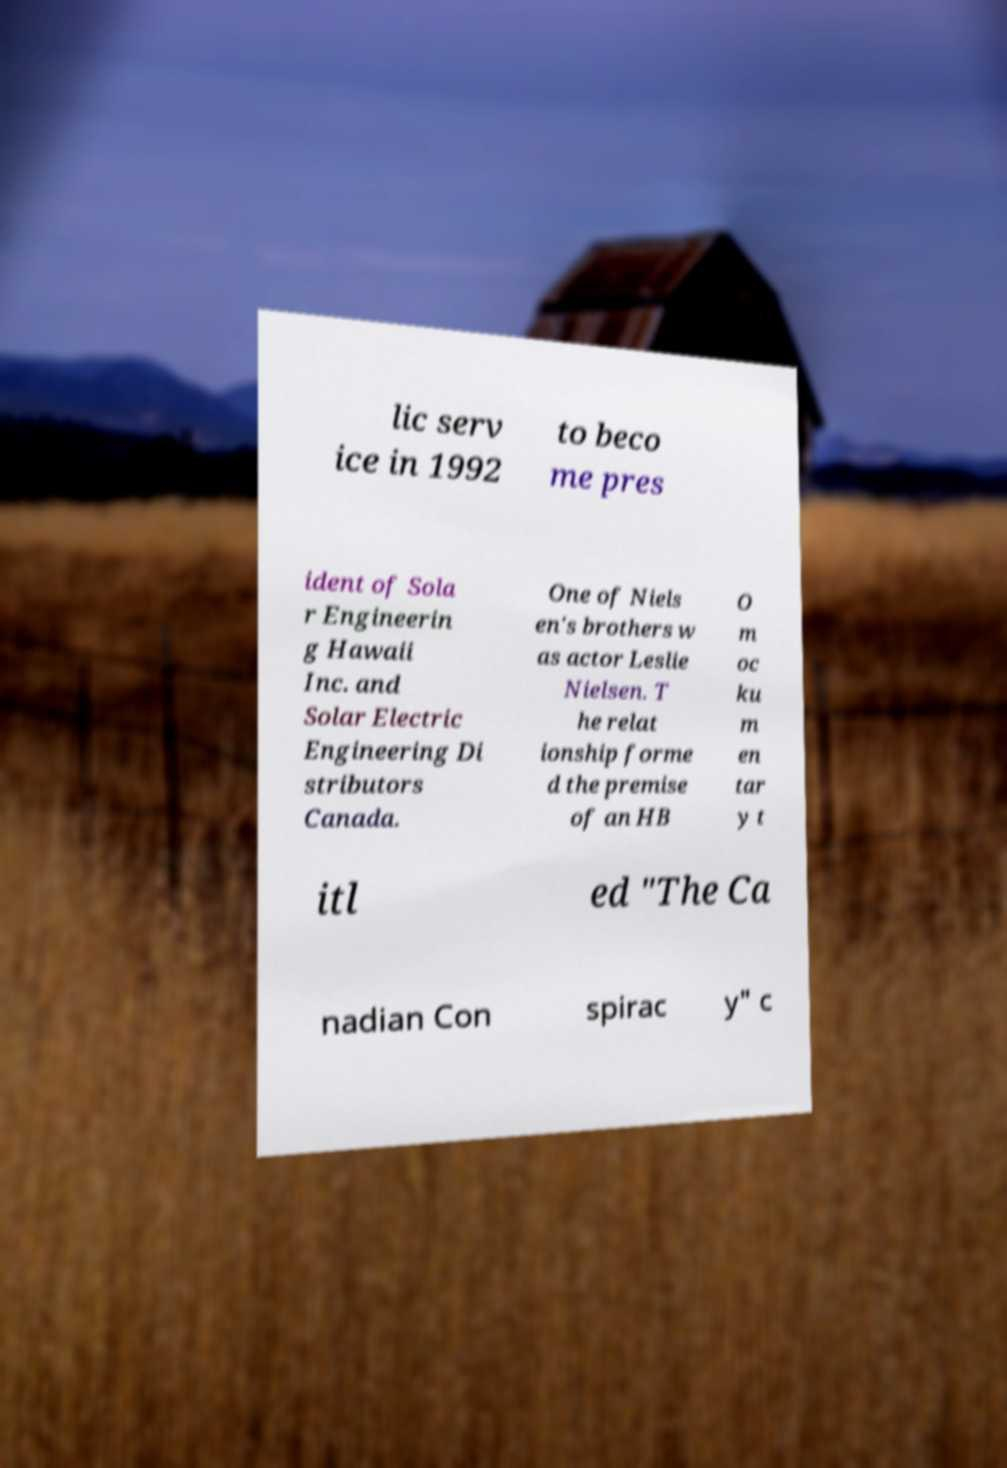Could you extract and type out the text from this image? lic serv ice in 1992 to beco me pres ident of Sola r Engineerin g Hawaii Inc. and Solar Electric Engineering Di stributors Canada. One of Niels en's brothers w as actor Leslie Nielsen. T he relat ionship forme d the premise of an HB O m oc ku m en tar y t itl ed "The Ca nadian Con spirac y" c 